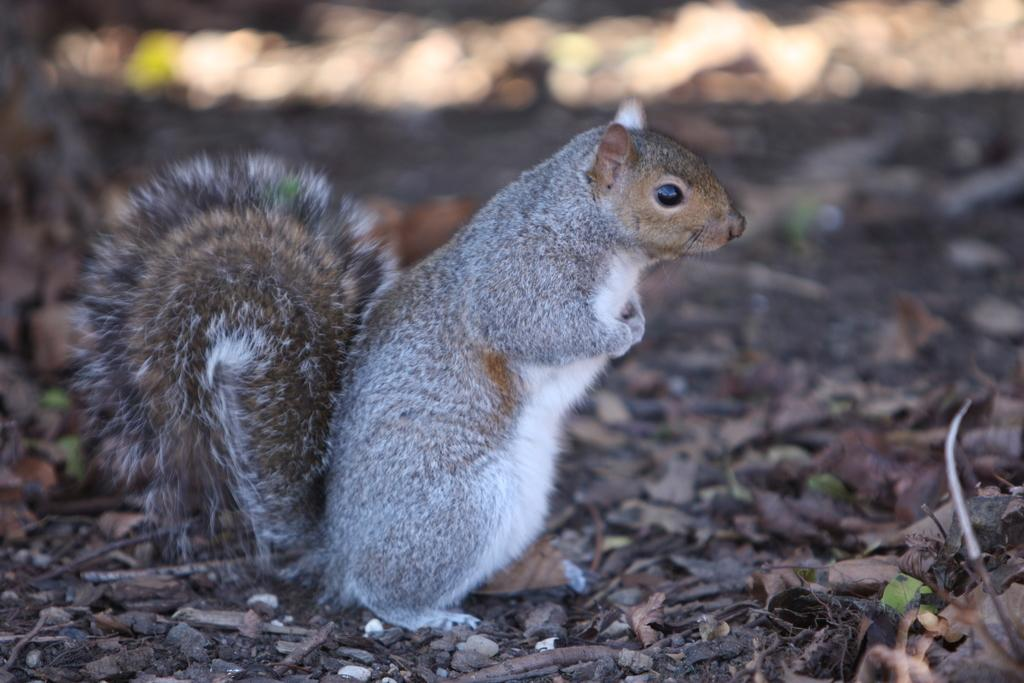What animal can be seen in the image? There is a squirrel in the image. How is the squirrel positioned in relation to the other elements in the image? The squirrel is in front of the other elements in the image. What type of vegetation is present on the ground in the image? There are leaves and sticks on the ground in the image. What can be observed about the background of the image? The background of the image is blurred. Is there a knife being used by the squirrel in the image? No, there is no knife present in the image, and the squirrel is not using any tool. What type of event is taking place in the image? There is no event depicted in the image; it simply shows a squirrel in front of leaves and sticks on the ground. 